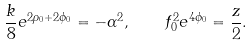<formula> <loc_0><loc_0><loc_500><loc_500>\frac { k } { 8 } e ^ { 2 \rho _ { 0 } + 2 \phi _ { 0 } } = - \alpha ^ { 2 } , \quad f _ { 0 } ^ { 2 } e ^ { 4 \phi _ { 0 } } = \frac { z } { 2 } .</formula> 